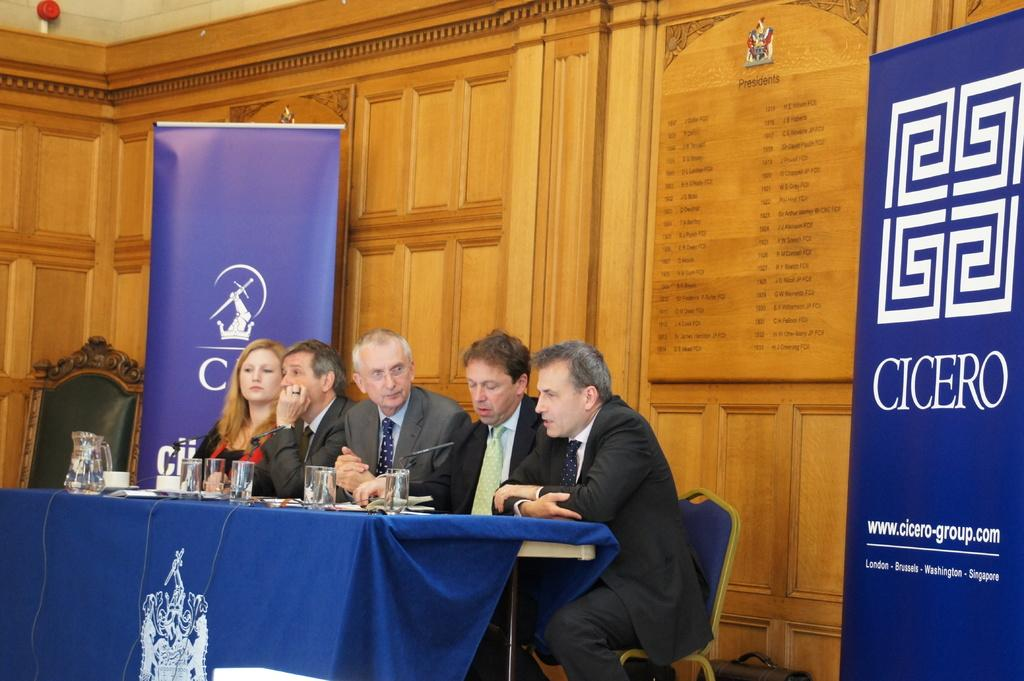How many men are in the image wearing suits? There are four men in suits in the image. What is the woman in the image doing? The woman is sitting in front of a table and holding a mic. What can be seen on the table in the image? There is a water glass and a jug on the table. What is behind the people in the image? There is a wall behind the people in the image. What is on either side of the wall in the image? There are posters on either side of the wall. What type of soup is being served in the image? There is no soup present in the image. Can you describe the spot on the wall where the posters are hanging? There is no mention of a spot on the wall in the image; only the presence of posters is noted. 